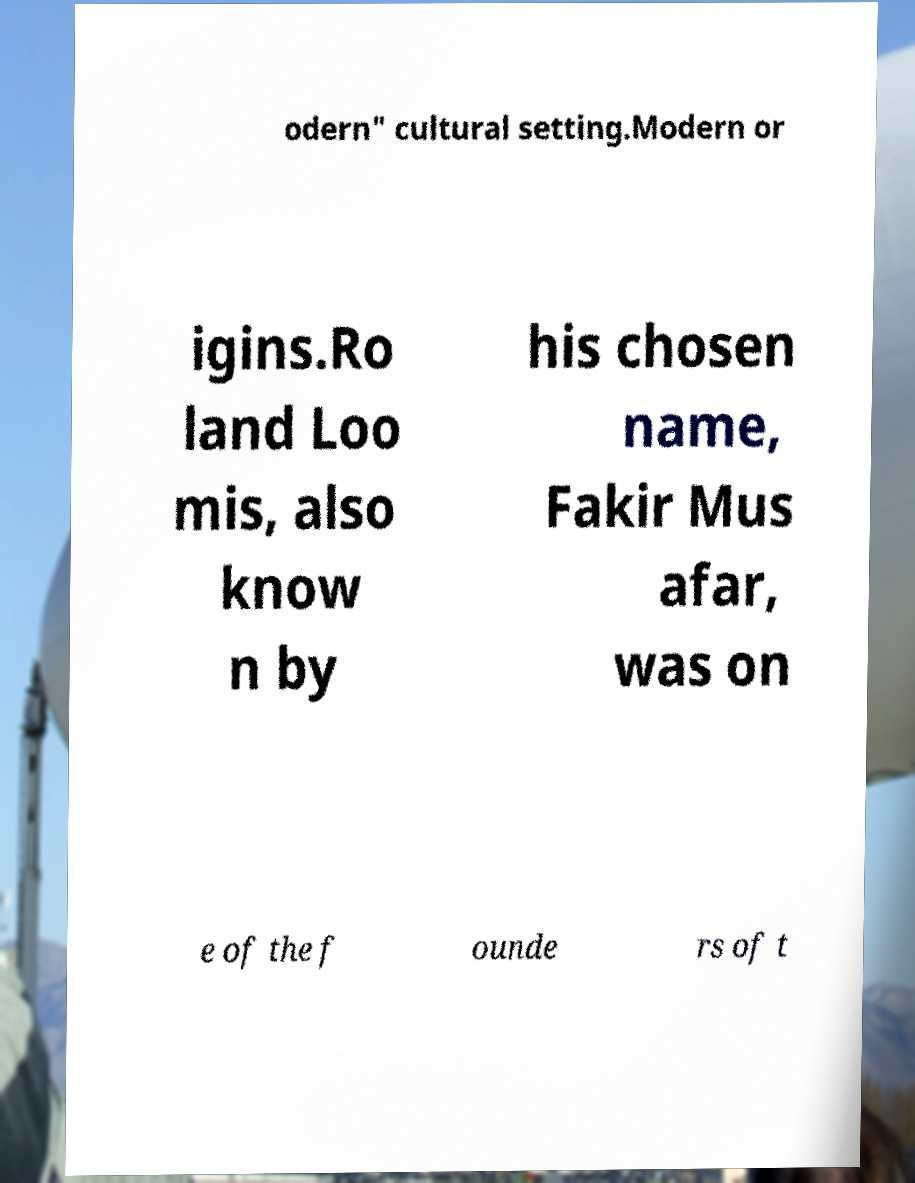For documentation purposes, I need the text within this image transcribed. Could you provide that? odern" cultural setting.Modern or igins.Ro land Loo mis, also know n by his chosen name, Fakir Mus afar, was on e of the f ounde rs of t 